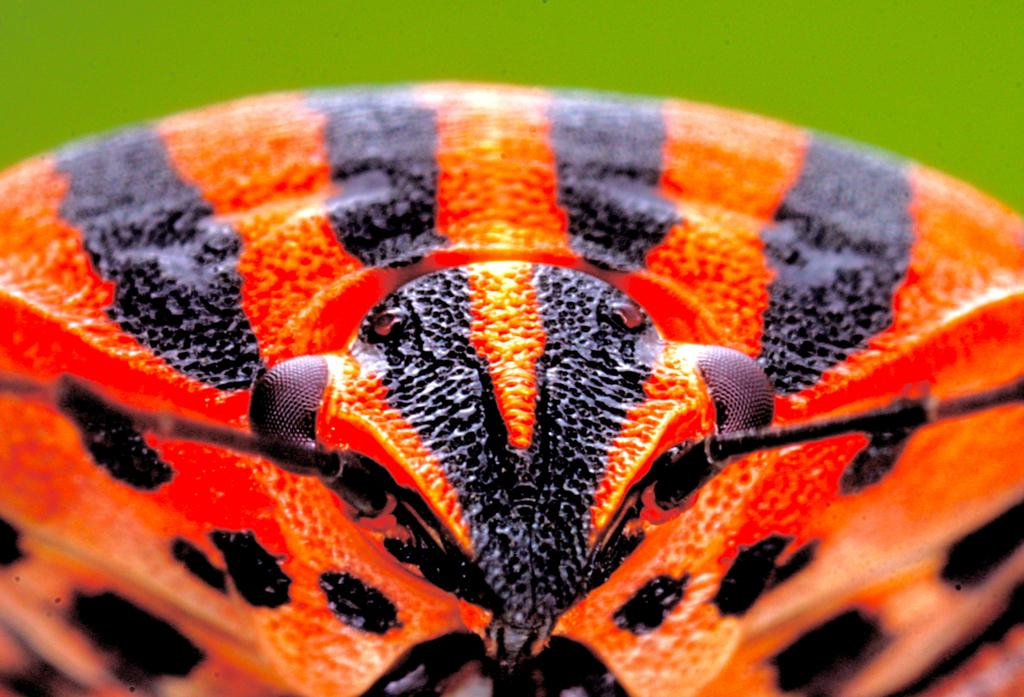What type of image is being shown? The image is a macro image. What is the main subject of the image? The subject of the image is an insect. Can you describe the colors of the insect? The insect has red and black colors. What type of stone is the insect sitting on in the image? There is no stone present in the image; it is a macro image of an insect with red and black colors. Can you tell me the relationship between the insect and the father in the image? There is no father present in the image, as it is a macro image of an insect. 